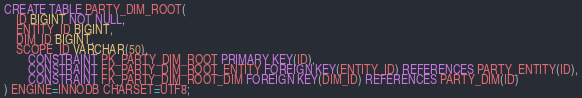Convert code to text. <code><loc_0><loc_0><loc_500><loc_500><_SQL_>
CREATE TABLE PARTY_DIM_ROOT(
	ID BIGINT NOT NULL,
	ENTITY_ID BIGINT,
	DIM_ID BIGINT,
	SCOPE_ID VARCHAR(50),
        CONSTRAINT PK_PARTY_DIM_ROOT PRIMARY KEY(ID),
        CONSTRAINT FK_PARTY_DIM_ROOT_ENTITY FOREIGN KEY(ENTITY_ID) REFERENCES PARTY_ENTITY(ID),
        CONSTRAINT FK_PARTY_DIM_ROOT_DIM FOREIGN KEY(DIM_ID) REFERENCES PARTY_DIM(ID)
) ENGINE=INNODB CHARSET=UTF8;
</code> 